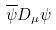<formula> <loc_0><loc_0><loc_500><loc_500>\overline { \psi } D _ { \mu } \psi</formula> 